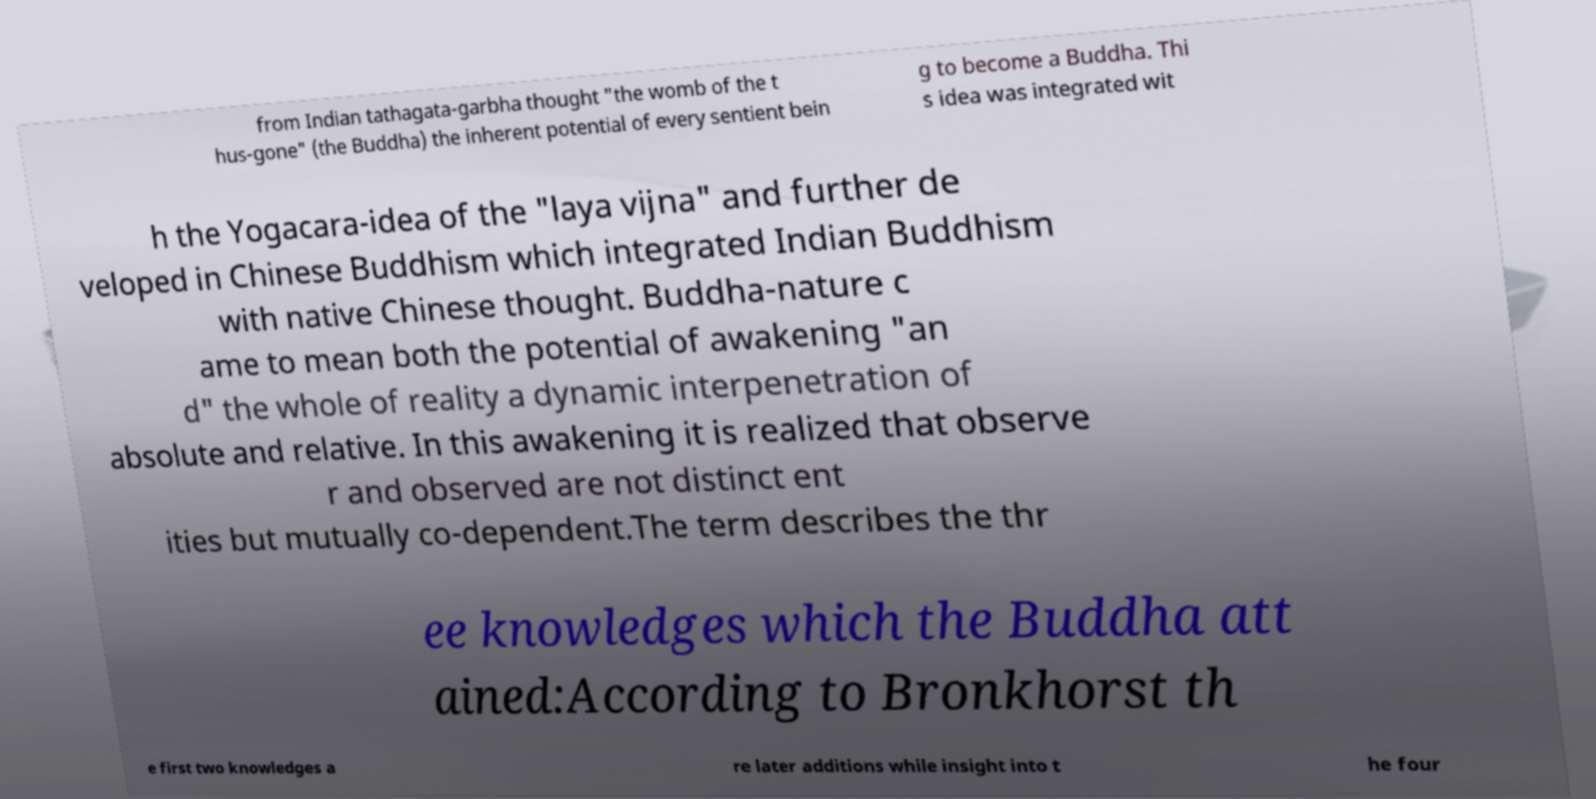Please read and relay the text visible in this image. What does it say? from Indian tathagata-garbha thought "the womb of the t hus-gone" (the Buddha) the inherent potential of every sentient bein g to become a Buddha. Thi s idea was integrated wit h the Yogacara-idea of the "laya vijna" and further de veloped in Chinese Buddhism which integrated Indian Buddhism with native Chinese thought. Buddha-nature c ame to mean both the potential of awakening "an d" the whole of reality a dynamic interpenetration of absolute and relative. In this awakening it is realized that observe r and observed are not distinct ent ities but mutually co-dependent.The term describes the thr ee knowledges which the Buddha att ained:According to Bronkhorst th e first two knowledges a re later additions while insight into t he four 